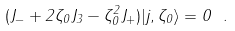<formula> <loc_0><loc_0><loc_500><loc_500>( J _ { - } + 2 \zeta _ { 0 } J _ { 3 } - \zeta _ { 0 } ^ { 2 } J _ { + } ) | j , \zeta _ { 0 } \rangle = 0 \ .</formula> 